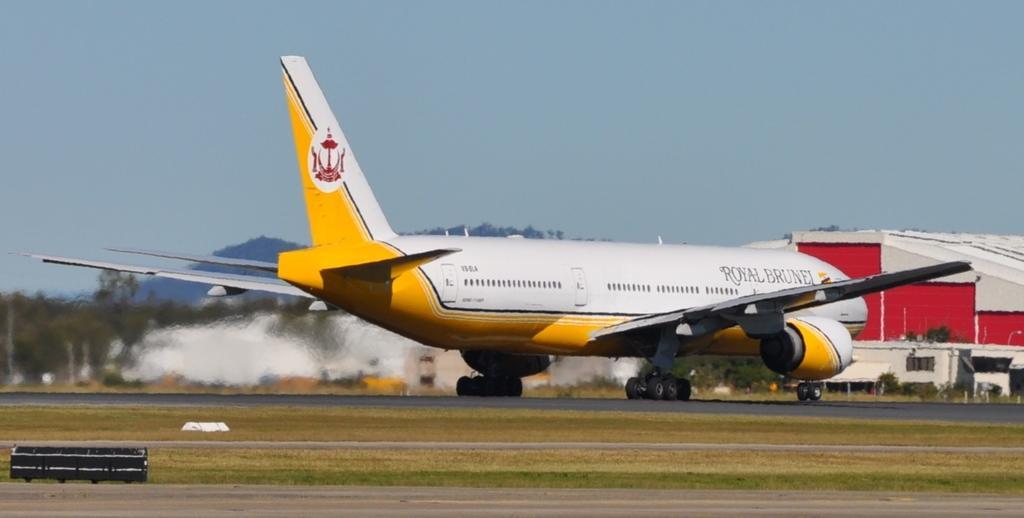Describe this image in one or two sentences. In this picture, we can see an airplane moving on the road. On the right side, we can see a building. On the left side, we can see a snow. In the background, we can see some mountains, trees. On the top, we can see a sky, at the bottom there is a grass and a road. 